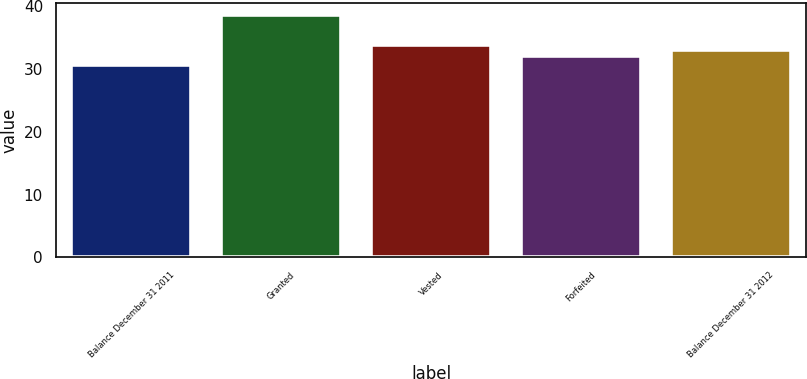Convert chart. <chart><loc_0><loc_0><loc_500><loc_500><bar_chart><fcel>Balance December 31 2011<fcel>Granted<fcel>Vested<fcel>Forfeited<fcel>Balance December 31 2012<nl><fcel>30.65<fcel>38.62<fcel>33.88<fcel>32.07<fcel>33.08<nl></chart> 